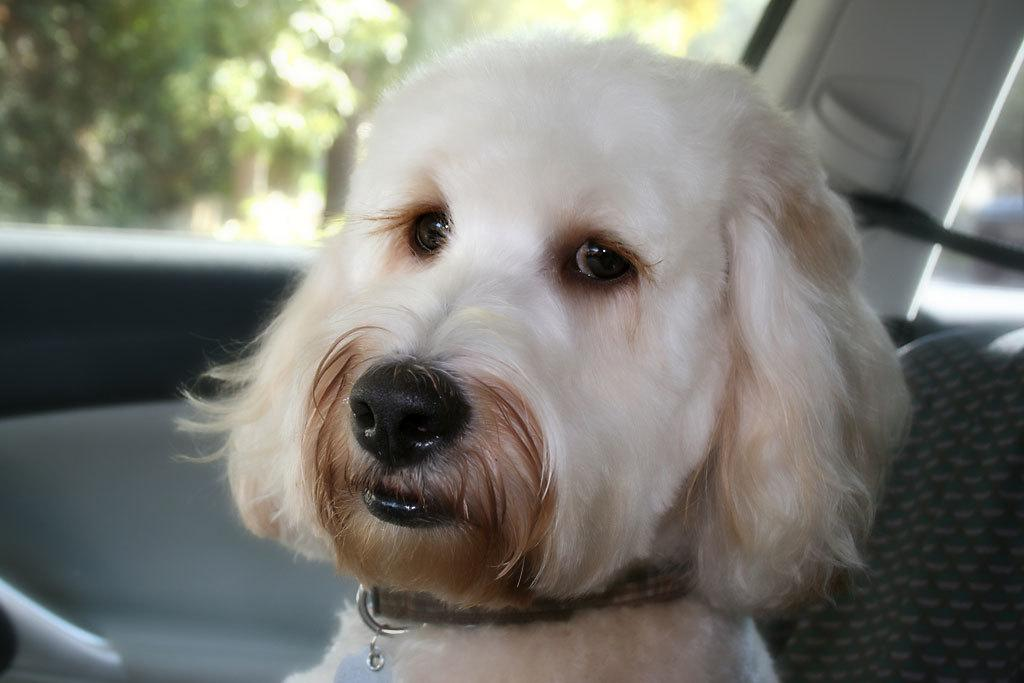What type of animal is in the image? There is a dog in the image. Where is the dog sitting? The dog is sitting on a seat. What is the location of the seat? The seat is inside a car. What can be seen outside the car? Trees are visible from the window of the car. Is there a ghost visible in the image? No, there is no ghost present in the image. What type of poison is the dog consuming in the image? There is no indication in the image that the dog is consuming any poison. 